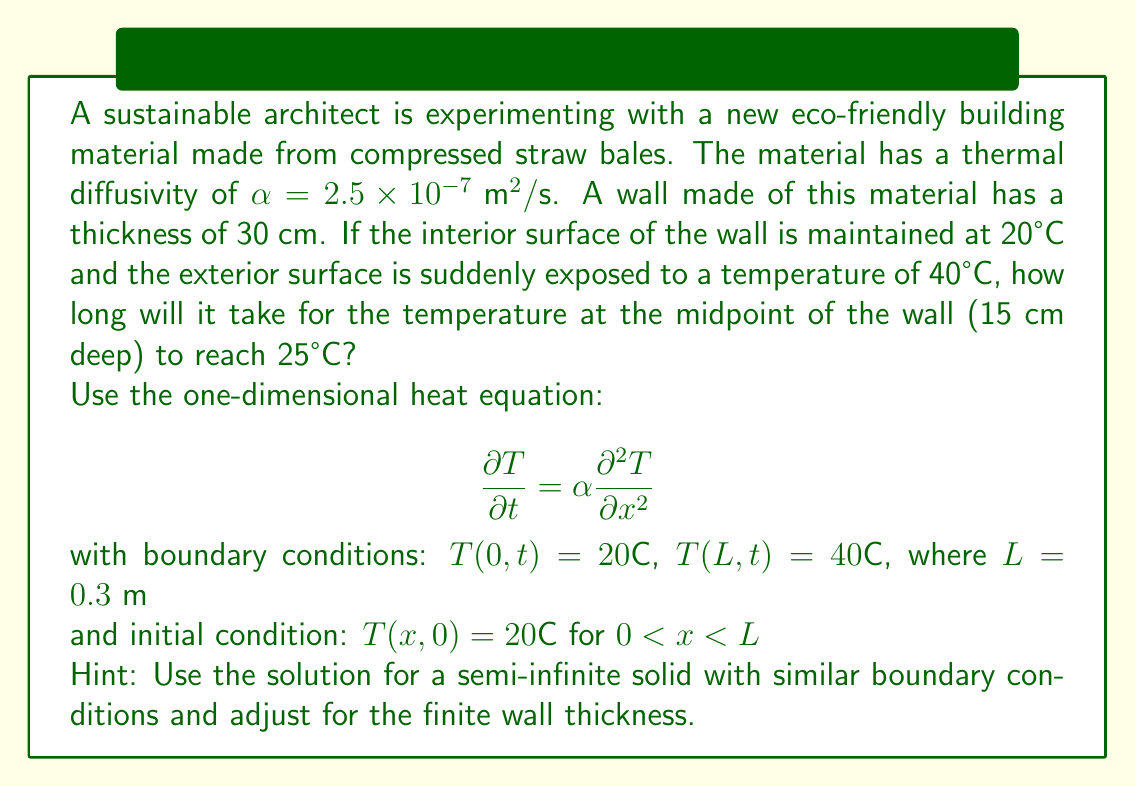Teach me how to tackle this problem. Let's approach this step-by-step:

1) The solution for a semi-infinite solid with similar boundary conditions is:

   $$ T(x,t) = T_i + (T_s - T_i) \text{erfc}\left(\frac{x}{2\sqrt{\alpha t}}\right) $$

   where $T_i$ is the initial temperature and $T_s$ is the surface temperature.

2) To adjust for the finite wall, we can use the method of superposition:

   $$ T(x,t) = 20 + 20 \left[\text{erfc}\left(\frac{x}{2\sqrt{\alpha t}}\right) - \text{erfc}\left(\frac{2L-x}{2\sqrt{\alpha t}}\right)\right] $$

3) We want to find $t$ when $T(L/2,t) = 25°\text{C}$. Substituting $x = L/2 = 0.15 \text{ m}$:

   $$ 25 = 20 + 20 \left[\text{erfc}\left(\frac{0.15}{2\sqrt{\alpha t}}\right) - \text{erfc}\left(\frac{0.45}{2\sqrt{\alpha t}}\right)\right] $$

4) Simplify:

   $$ 0.25 = \text{erfc}\left(\frac{0.15}{2\sqrt{\alpha t}}\right) - \text{erfc}\left(\frac{0.45}{2\sqrt{\alpha t}}\right) $$

5) This equation can't be solved analytically. We need to use numerical methods or look-up tables for the complementary error function.

6) By trial and error or using a computer solver, we find:

   $$ \frac{0.15}{2\sqrt{\alpha t}} \approx 0.5384 $$

7) Solving for $t$:

   $$ t = \frac{0.15^2}{4\alpha(0.5384)^2} = \frac{0.0225}{4(2.5 \times 10^{-7})(0.2899)} \approx 7722 \text{ s} $$

8) Converting to hours:

   $$ t \approx 7722 / 3600 \approx 2.15 \text{ hours} $$
Answer: 2.15 hours 